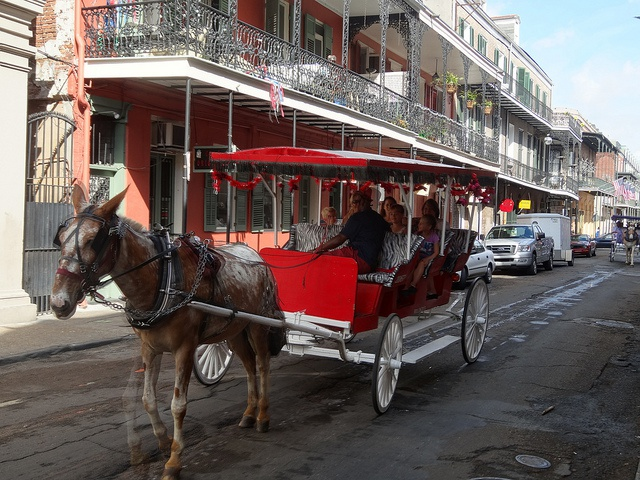Describe the objects in this image and their specific colors. I can see horse in gray, black, maroon, and darkgray tones, truck in gray, black, darkgray, and lightgray tones, people in gray, black, maroon, and brown tones, truck in gray, darkgray, and lightgray tones, and people in gray, black, maroon, and purple tones in this image. 